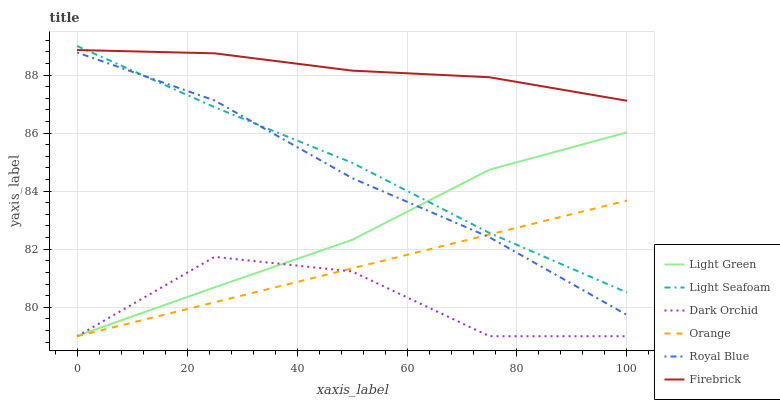Does Dark Orchid have the minimum area under the curve?
Answer yes or no. Yes. Does Firebrick have the maximum area under the curve?
Answer yes or no. Yes. Does Royal Blue have the minimum area under the curve?
Answer yes or no. No. Does Royal Blue have the maximum area under the curve?
Answer yes or no. No. Is Orange the smoothest?
Answer yes or no. Yes. Is Dark Orchid the roughest?
Answer yes or no. Yes. Is Royal Blue the smoothest?
Answer yes or no. No. Is Royal Blue the roughest?
Answer yes or no. No. Does Dark Orchid have the lowest value?
Answer yes or no. Yes. Does Royal Blue have the lowest value?
Answer yes or no. No. Does Light Seafoam have the highest value?
Answer yes or no. Yes. Does Royal Blue have the highest value?
Answer yes or no. No. Is Orange less than Light Green?
Answer yes or no. Yes. Is Light Seafoam greater than Dark Orchid?
Answer yes or no. Yes. Does Orange intersect Royal Blue?
Answer yes or no. Yes. Is Orange less than Royal Blue?
Answer yes or no. No. Is Orange greater than Royal Blue?
Answer yes or no. No. Does Orange intersect Light Green?
Answer yes or no. No. 